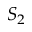Convert formula to latex. <formula><loc_0><loc_0><loc_500><loc_500>S _ { 2 }</formula> 